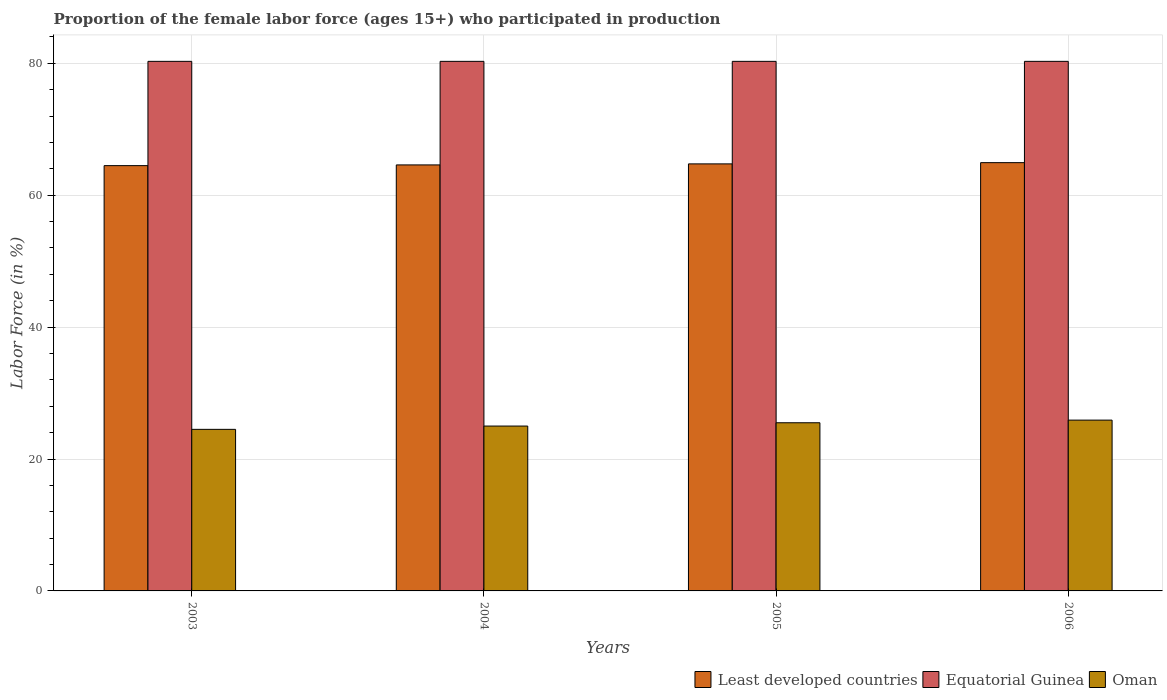How many different coloured bars are there?
Keep it short and to the point. 3. Are the number of bars per tick equal to the number of legend labels?
Make the answer very short. Yes. Are the number of bars on each tick of the X-axis equal?
Offer a very short reply. Yes. In how many cases, is the number of bars for a given year not equal to the number of legend labels?
Make the answer very short. 0. What is the proportion of the female labor force who participated in production in Equatorial Guinea in 2005?
Offer a very short reply. 80.3. Across all years, what is the maximum proportion of the female labor force who participated in production in Least developed countries?
Keep it short and to the point. 64.94. Across all years, what is the minimum proportion of the female labor force who participated in production in Least developed countries?
Provide a succinct answer. 64.49. What is the total proportion of the female labor force who participated in production in Least developed countries in the graph?
Provide a succinct answer. 258.78. What is the difference between the proportion of the female labor force who participated in production in Oman in 2005 and the proportion of the female labor force who participated in production in Least developed countries in 2003?
Your response must be concise. -38.99. What is the average proportion of the female labor force who participated in production in Equatorial Guinea per year?
Provide a short and direct response. 80.3. In the year 2006, what is the difference between the proportion of the female labor force who participated in production in Oman and proportion of the female labor force who participated in production in Equatorial Guinea?
Provide a succinct answer. -54.4. In how many years, is the proportion of the female labor force who participated in production in Equatorial Guinea greater than 8 %?
Offer a terse response. 4. What is the ratio of the proportion of the female labor force who participated in production in Least developed countries in 2005 to that in 2006?
Make the answer very short. 1. Is the proportion of the female labor force who participated in production in Least developed countries in 2004 less than that in 2005?
Provide a succinct answer. Yes. Is the difference between the proportion of the female labor force who participated in production in Oman in 2003 and 2005 greater than the difference between the proportion of the female labor force who participated in production in Equatorial Guinea in 2003 and 2005?
Provide a short and direct response. No. What is the difference between the highest and the lowest proportion of the female labor force who participated in production in Oman?
Ensure brevity in your answer.  1.4. In how many years, is the proportion of the female labor force who participated in production in Oman greater than the average proportion of the female labor force who participated in production in Oman taken over all years?
Ensure brevity in your answer.  2. What does the 2nd bar from the left in 2004 represents?
Ensure brevity in your answer.  Equatorial Guinea. What does the 1st bar from the right in 2006 represents?
Ensure brevity in your answer.  Oman. Is it the case that in every year, the sum of the proportion of the female labor force who participated in production in Oman and proportion of the female labor force who participated in production in Equatorial Guinea is greater than the proportion of the female labor force who participated in production in Least developed countries?
Your answer should be compact. Yes. How many bars are there?
Provide a succinct answer. 12. Are the values on the major ticks of Y-axis written in scientific E-notation?
Ensure brevity in your answer.  No. Does the graph contain grids?
Offer a terse response. Yes. Where does the legend appear in the graph?
Your answer should be compact. Bottom right. How many legend labels are there?
Your answer should be very brief. 3. What is the title of the graph?
Give a very brief answer. Proportion of the female labor force (ages 15+) who participated in production. What is the label or title of the X-axis?
Keep it short and to the point. Years. What is the Labor Force (in %) of Least developed countries in 2003?
Ensure brevity in your answer.  64.49. What is the Labor Force (in %) in Equatorial Guinea in 2003?
Your answer should be very brief. 80.3. What is the Labor Force (in %) of Least developed countries in 2004?
Your answer should be compact. 64.6. What is the Labor Force (in %) of Equatorial Guinea in 2004?
Keep it short and to the point. 80.3. What is the Labor Force (in %) in Oman in 2004?
Offer a terse response. 25. What is the Labor Force (in %) in Least developed countries in 2005?
Provide a succinct answer. 64.75. What is the Labor Force (in %) in Equatorial Guinea in 2005?
Offer a very short reply. 80.3. What is the Labor Force (in %) in Oman in 2005?
Offer a terse response. 25.5. What is the Labor Force (in %) of Least developed countries in 2006?
Offer a terse response. 64.94. What is the Labor Force (in %) in Equatorial Guinea in 2006?
Keep it short and to the point. 80.3. What is the Labor Force (in %) of Oman in 2006?
Provide a succinct answer. 25.9. Across all years, what is the maximum Labor Force (in %) of Least developed countries?
Keep it short and to the point. 64.94. Across all years, what is the maximum Labor Force (in %) of Equatorial Guinea?
Give a very brief answer. 80.3. Across all years, what is the maximum Labor Force (in %) in Oman?
Your response must be concise. 25.9. Across all years, what is the minimum Labor Force (in %) of Least developed countries?
Your answer should be compact. 64.49. Across all years, what is the minimum Labor Force (in %) in Equatorial Guinea?
Give a very brief answer. 80.3. What is the total Labor Force (in %) of Least developed countries in the graph?
Offer a very short reply. 258.78. What is the total Labor Force (in %) in Equatorial Guinea in the graph?
Offer a very short reply. 321.2. What is the total Labor Force (in %) in Oman in the graph?
Keep it short and to the point. 100.9. What is the difference between the Labor Force (in %) of Least developed countries in 2003 and that in 2004?
Provide a short and direct response. -0.11. What is the difference between the Labor Force (in %) of Equatorial Guinea in 2003 and that in 2004?
Offer a very short reply. 0. What is the difference between the Labor Force (in %) in Least developed countries in 2003 and that in 2005?
Offer a very short reply. -0.26. What is the difference between the Labor Force (in %) in Oman in 2003 and that in 2005?
Your response must be concise. -1. What is the difference between the Labor Force (in %) of Least developed countries in 2003 and that in 2006?
Give a very brief answer. -0.45. What is the difference between the Labor Force (in %) of Equatorial Guinea in 2003 and that in 2006?
Provide a succinct answer. 0. What is the difference between the Labor Force (in %) in Oman in 2003 and that in 2006?
Your answer should be very brief. -1.4. What is the difference between the Labor Force (in %) of Least developed countries in 2004 and that in 2005?
Offer a terse response. -0.16. What is the difference between the Labor Force (in %) of Equatorial Guinea in 2004 and that in 2005?
Ensure brevity in your answer.  0. What is the difference between the Labor Force (in %) in Oman in 2004 and that in 2005?
Keep it short and to the point. -0.5. What is the difference between the Labor Force (in %) of Least developed countries in 2004 and that in 2006?
Your answer should be very brief. -0.34. What is the difference between the Labor Force (in %) of Equatorial Guinea in 2004 and that in 2006?
Keep it short and to the point. 0. What is the difference between the Labor Force (in %) in Least developed countries in 2005 and that in 2006?
Keep it short and to the point. -0.19. What is the difference between the Labor Force (in %) of Oman in 2005 and that in 2006?
Offer a terse response. -0.4. What is the difference between the Labor Force (in %) of Least developed countries in 2003 and the Labor Force (in %) of Equatorial Guinea in 2004?
Provide a succinct answer. -15.81. What is the difference between the Labor Force (in %) of Least developed countries in 2003 and the Labor Force (in %) of Oman in 2004?
Ensure brevity in your answer.  39.49. What is the difference between the Labor Force (in %) of Equatorial Guinea in 2003 and the Labor Force (in %) of Oman in 2004?
Provide a succinct answer. 55.3. What is the difference between the Labor Force (in %) of Least developed countries in 2003 and the Labor Force (in %) of Equatorial Guinea in 2005?
Provide a succinct answer. -15.81. What is the difference between the Labor Force (in %) in Least developed countries in 2003 and the Labor Force (in %) in Oman in 2005?
Provide a short and direct response. 38.99. What is the difference between the Labor Force (in %) of Equatorial Guinea in 2003 and the Labor Force (in %) of Oman in 2005?
Make the answer very short. 54.8. What is the difference between the Labor Force (in %) in Least developed countries in 2003 and the Labor Force (in %) in Equatorial Guinea in 2006?
Provide a short and direct response. -15.81. What is the difference between the Labor Force (in %) of Least developed countries in 2003 and the Labor Force (in %) of Oman in 2006?
Offer a very short reply. 38.59. What is the difference between the Labor Force (in %) of Equatorial Guinea in 2003 and the Labor Force (in %) of Oman in 2006?
Offer a terse response. 54.4. What is the difference between the Labor Force (in %) in Least developed countries in 2004 and the Labor Force (in %) in Equatorial Guinea in 2005?
Provide a short and direct response. -15.7. What is the difference between the Labor Force (in %) of Least developed countries in 2004 and the Labor Force (in %) of Oman in 2005?
Keep it short and to the point. 39.1. What is the difference between the Labor Force (in %) of Equatorial Guinea in 2004 and the Labor Force (in %) of Oman in 2005?
Keep it short and to the point. 54.8. What is the difference between the Labor Force (in %) of Least developed countries in 2004 and the Labor Force (in %) of Equatorial Guinea in 2006?
Make the answer very short. -15.7. What is the difference between the Labor Force (in %) of Least developed countries in 2004 and the Labor Force (in %) of Oman in 2006?
Ensure brevity in your answer.  38.7. What is the difference between the Labor Force (in %) of Equatorial Guinea in 2004 and the Labor Force (in %) of Oman in 2006?
Provide a succinct answer. 54.4. What is the difference between the Labor Force (in %) in Least developed countries in 2005 and the Labor Force (in %) in Equatorial Guinea in 2006?
Provide a succinct answer. -15.55. What is the difference between the Labor Force (in %) in Least developed countries in 2005 and the Labor Force (in %) in Oman in 2006?
Make the answer very short. 38.85. What is the difference between the Labor Force (in %) of Equatorial Guinea in 2005 and the Labor Force (in %) of Oman in 2006?
Keep it short and to the point. 54.4. What is the average Labor Force (in %) of Least developed countries per year?
Keep it short and to the point. 64.69. What is the average Labor Force (in %) of Equatorial Guinea per year?
Keep it short and to the point. 80.3. What is the average Labor Force (in %) of Oman per year?
Ensure brevity in your answer.  25.23. In the year 2003, what is the difference between the Labor Force (in %) in Least developed countries and Labor Force (in %) in Equatorial Guinea?
Ensure brevity in your answer.  -15.81. In the year 2003, what is the difference between the Labor Force (in %) of Least developed countries and Labor Force (in %) of Oman?
Your answer should be compact. 39.99. In the year 2003, what is the difference between the Labor Force (in %) in Equatorial Guinea and Labor Force (in %) in Oman?
Provide a succinct answer. 55.8. In the year 2004, what is the difference between the Labor Force (in %) in Least developed countries and Labor Force (in %) in Equatorial Guinea?
Give a very brief answer. -15.7. In the year 2004, what is the difference between the Labor Force (in %) in Least developed countries and Labor Force (in %) in Oman?
Offer a terse response. 39.6. In the year 2004, what is the difference between the Labor Force (in %) of Equatorial Guinea and Labor Force (in %) of Oman?
Your answer should be compact. 55.3. In the year 2005, what is the difference between the Labor Force (in %) in Least developed countries and Labor Force (in %) in Equatorial Guinea?
Keep it short and to the point. -15.55. In the year 2005, what is the difference between the Labor Force (in %) of Least developed countries and Labor Force (in %) of Oman?
Your answer should be compact. 39.25. In the year 2005, what is the difference between the Labor Force (in %) in Equatorial Guinea and Labor Force (in %) in Oman?
Keep it short and to the point. 54.8. In the year 2006, what is the difference between the Labor Force (in %) of Least developed countries and Labor Force (in %) of Equatorial Guinea?
Your answer should be very brief. -15.36. In the year 2006, what is the difference between the Labor Force (in %) of Least developed countries and Labor Force (in %) of Oman?
Offer a terse response. 39.04. In the year 2006, what is the difference between the Labor Force (in %) of Equatorial Guinea and Labor Force (in %) of Oman?
Ensure brevity in your answer.  54.4. What is the ratio of the Labor Force (in %) in Least developed countries in 2003 to that in 2004?
Make the answer very short. 1. What is the ratio of the Labor Force (in %) in Oman in 2003 to that in 2004?
Give a very brief answer. 0.98. What is the ratio of the Labor Force (in %) in Least developed countries in 2003 to that in 2005?
Keep it short and to the point. 1. What is the ratio of the Labor Force (in %) of Equatorial Guinea in 2003 to that in 2005?
Make the answer very short. 1. What is the ratio of the Labor Force (in %) in Oman in 2003 to that in 2005?
Your response must be concise. 0.96. What is the ratio of the Labor Force (in %) of Least developed countries in 2003 to that in 2006?
Make the answer very short. 0.99. What is the ratio of the Labor Force (in %) in Oman in 2003 to that in 2006?
Your response must be concise. 0.95. What is the ratio of the Labor Force (in %) of Least developed countries in 2004 to that in 2005?
Ensure brevity in your answer.  1. What is the ratio of the Labor Force (in %) of Oman in 2004 to that in 2005?
Offer a terse response. 0.98. What is the ratio of the Labor Force (in %) in Equatorial Guinea in 2004 to that in 2006?
Your response must be concise. 1. What is the ratio of the Labor Force (in %) in Oman in 2004 to that in 2006?
Your answer should be very brief. 0.97. What is the ratio of the Labor Force (in %) of Oman in 2005 to that in 2006?
Give a very brief answer. 0.98. What is the difference between the highest and the second highest Labor Force (in %) in Least developed countries?
Your answer should be very brief. 0.19. What is the difference between the highest and the second highest Labor Force (in %) in Equatorial Guinea?
Your answer should be compact. 0. What is the difference between the highest and the second highest Labor Force (in %) of Oman?
Provide a short and direct response. 0.4. What is the difference between the highest and the lowest Labor Force (in %) of Least developed countries?
Ensure brevity in your answer.  0.45. What is the difference between the highest and the lowest Labor Force (in %) of Equatorial Guinea?
Your answer should be compact. 0. 